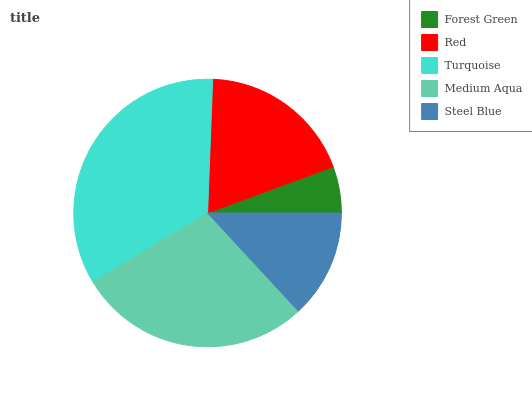Is Forest Green the minimum?
Answer yes or no. Yes. Is Turquoise the maximum?
Answer yes or no. Yes. Is Red the minimum?
Answer yes or no. No. Is Red the maximum?
Answer yes or no. No. Is Red greater than Forest Green?
Answer yes or no. Yes. Is Forest Green less than Red?
Answer yes or no. Yes. Is Forest Green greater than Red?
Answer yes or no. No. Is Red less than Forest Green?
Answer yes or no. No. Is Red the high median?
Answer yes or no. Yes. Is Red the low median?
Answer yes or no. Yes. Is Medium Aqua the high median?
Answer yes or no. No. Is Steel Blue the low median?
Answer yes or no. No. 